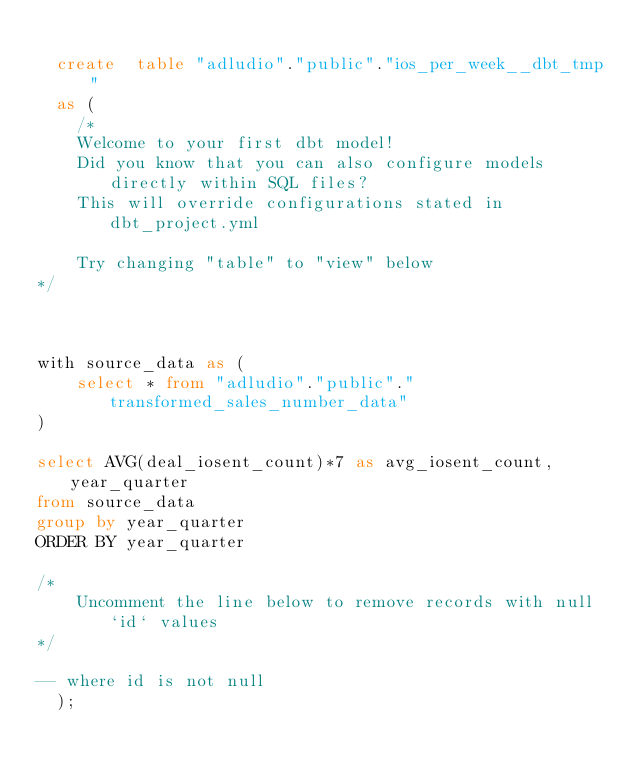Convert code to text. <code><loc_0><loc_0><loc_500><loc_500><_SQL_>
  create  table "adludio"."public"."ios_per_week__dbt_tmp"
  as (
    /*
    Welcome to your first dbt model!
    Did you know that you can also configure models directly within SQL files?
    This will override configurations stated in dbt_project.yml

    Try changing "table" to "view" below
*/



with source_data as (
    select * from "adludio"."public"."transformed_sales_number_data"
)

select AVG(deal_iosent_count)*7 as avg_iosent_count, year_quarter
from source_data
group by year_quarter
ORDER BY year_quarter

/*
    Uncomment the line below to remove records with null `id` values
*/

-- where id is not null
  );</code> 